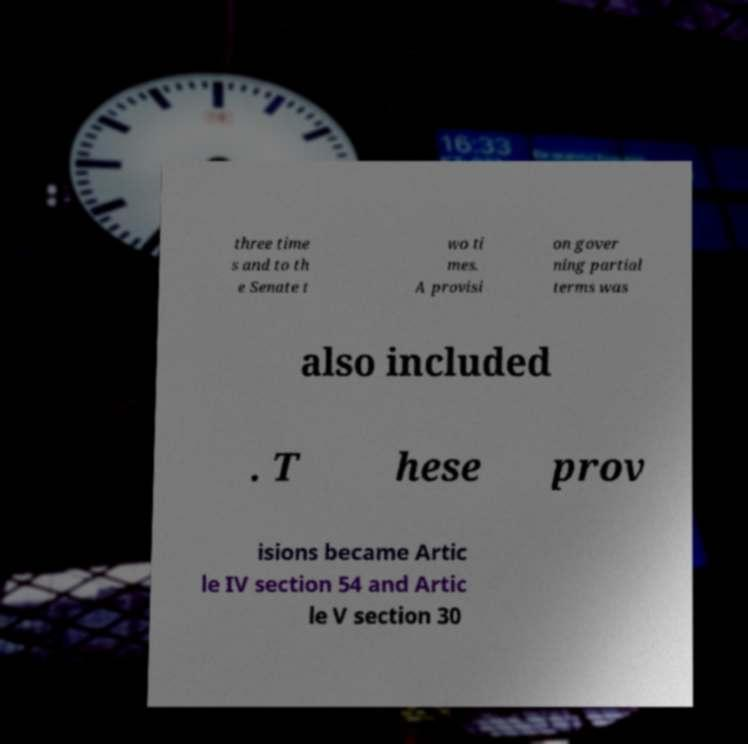Could you assist in decoding the text presented in this image and type it out clearly? three time s and to th e Senate t wo ti mes. A provisi on gover ning partial terms was also included . T hese prov isions became Artic le IV section 54 and Artic le V section 30 